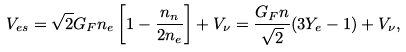Convert formula to latex. <formula><loc_0><loc_0><loc_500><loc_500>V _ { e s } = \sqrt { 2 } G _ { F } n _ { e } \left [ 1 - \frac { n _ { n } } { 2 n _ { e } } \right ] + V _ { \nu } = \frac { G _ { F } n } { \sqrt { 2 } } ( 3 Y _ { e } - 1 ) + V _ { \nu } ,</formula> 